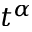<formula> <loc_0><loc_0><loc_500><loc_500>t ^ { \alpha }</formula> 